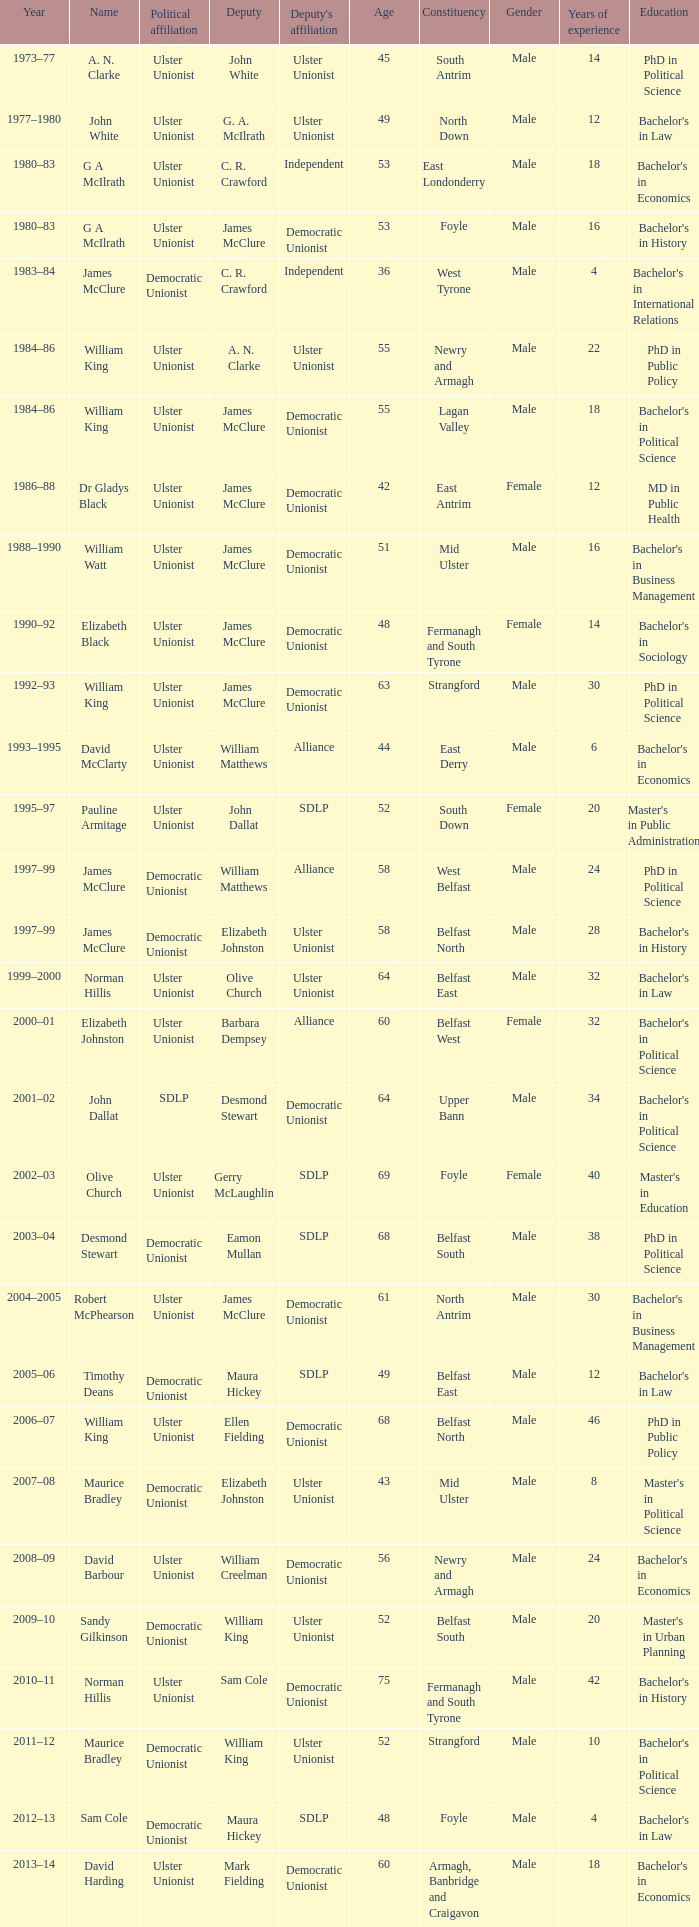What is the Name for 1997–99? James McClure, James McClure. 